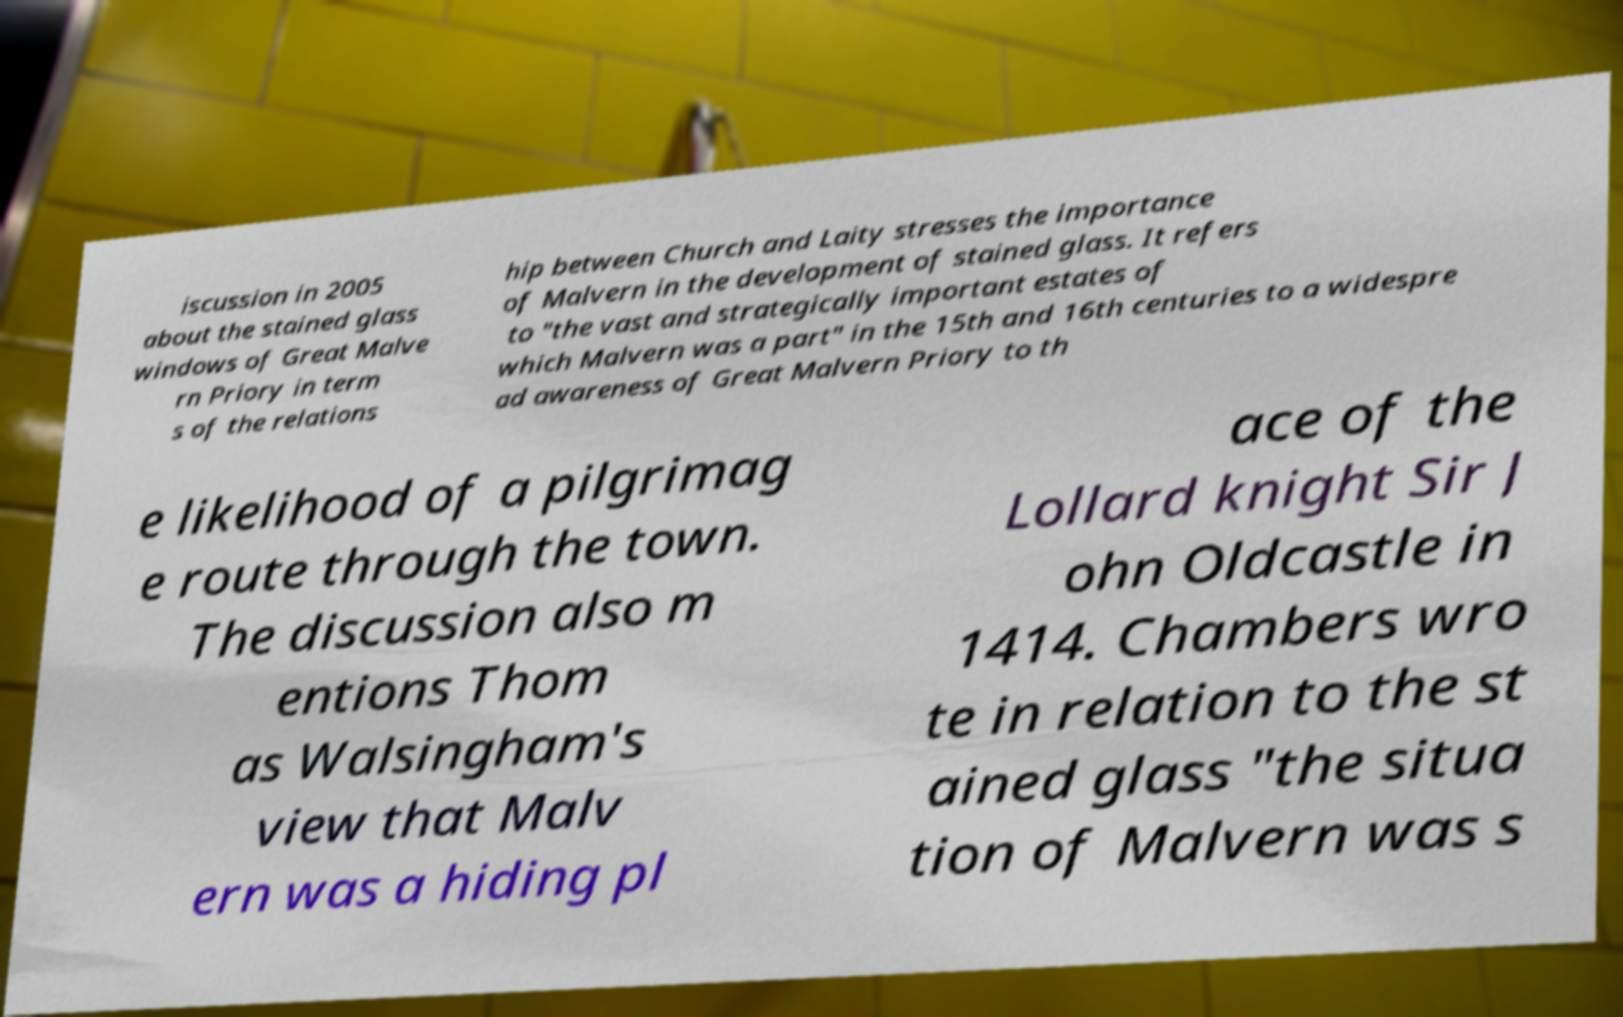Can you accurately transcribe the text from the provided image for me? iscussion in 2005 about the stained glass windows of Great Malve rn Priory in term s of the relations hip between Church and Laity stresses the importance of Malvern in the development of stained glass. It refers to "the vast and strategically important estates of which Malvern was a part" in the 15th and 16th centuries to a widespre ad awareness of Great Malvern Priory to th e likelihood of a pilgrimag e route through the town. The discussion also m entions Thom as Walsingham's view that Malv ern was a hiding pl ace of the Lollard knight Sir J ohn Oldcastle in 1414. Chambers wro te in relation to the st ained glass "the situa tion of Malvern was s 